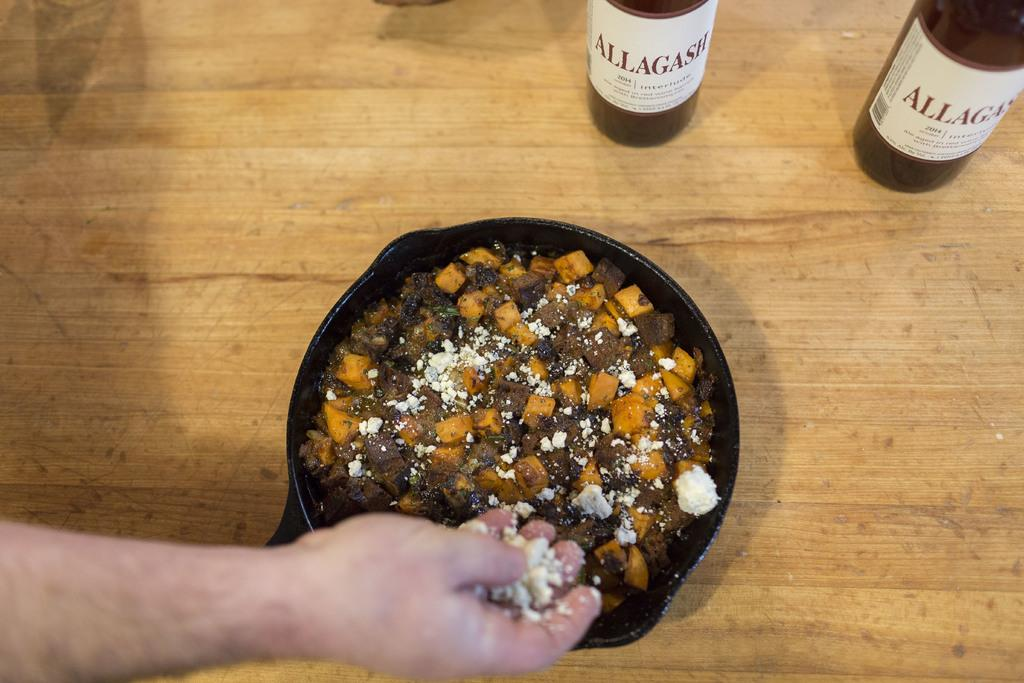Provide a one-sentence caption for the provided image. A person adds cheese to a dish next to bottles of 2014 Allagash. 